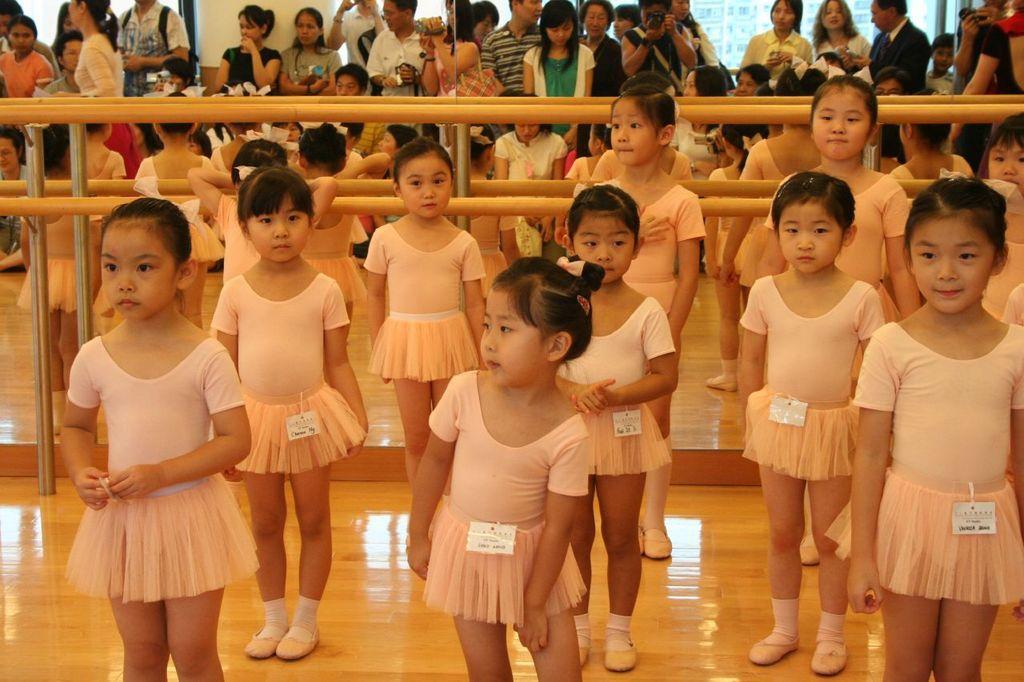Can you describe this image briefly? In the image I can see there are so many kids in the same costume standing on the stage, behind them there is a fence and other people standing. 